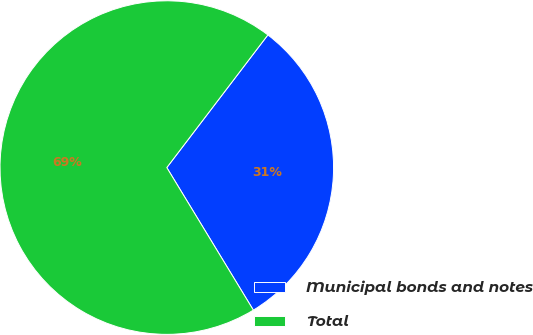<chart> <loc_0><loc_0><loc_500><loc_500><pie_chart><fcel>Municipal bonds and notes<fcel>Total<nl><fcel>30.95%<fcel>69.05%<nl></chart> 